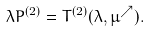Convert formula to latex. <formula><loc_0><loc_0><loc_500><loc_500>\lambda P ^ { ( 2 ) } = T ^ { ( 2 ) } ( \lambda , \mu ^ { \nearrow } ) .</formula> 